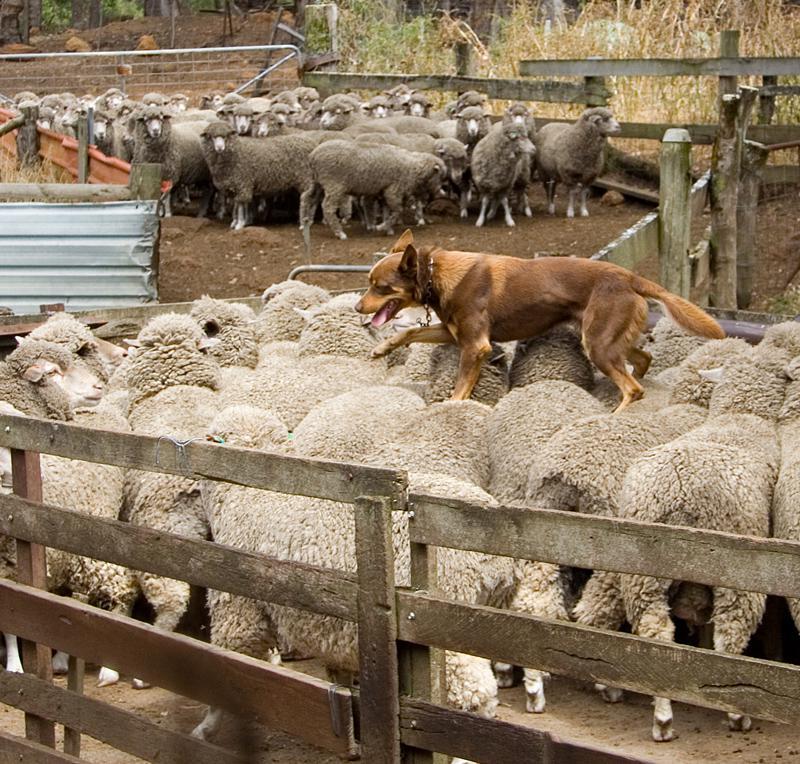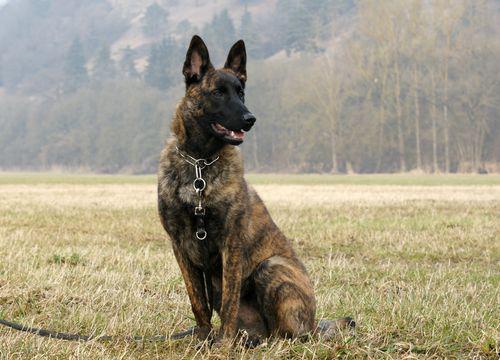The first image is the image on the left, the second image is the image on the right. For the images shown, is this caption "There are no more than two animals in the image on the right." true? Answer yes or no. Yes. 